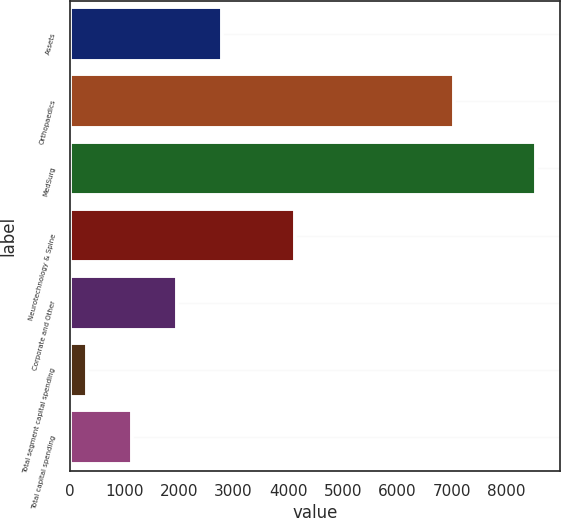Convert chart. <chart><loc_0><loc_0><loc_500><loc_500><bar_chart><fcel>Assets<fcel>Orthopaedics<fcel>MedSurg<fcel>Neurotechnology & Spine<fcel>Corporate and Other<fcel>Total segment capital spending<fcel>Total capital spending<nl><fcel>2780.8<fcel>7048<fcel>8553<fcel>4129<fcel>1956.2<fcel>307<fcel>1131.6<nl></chart> 